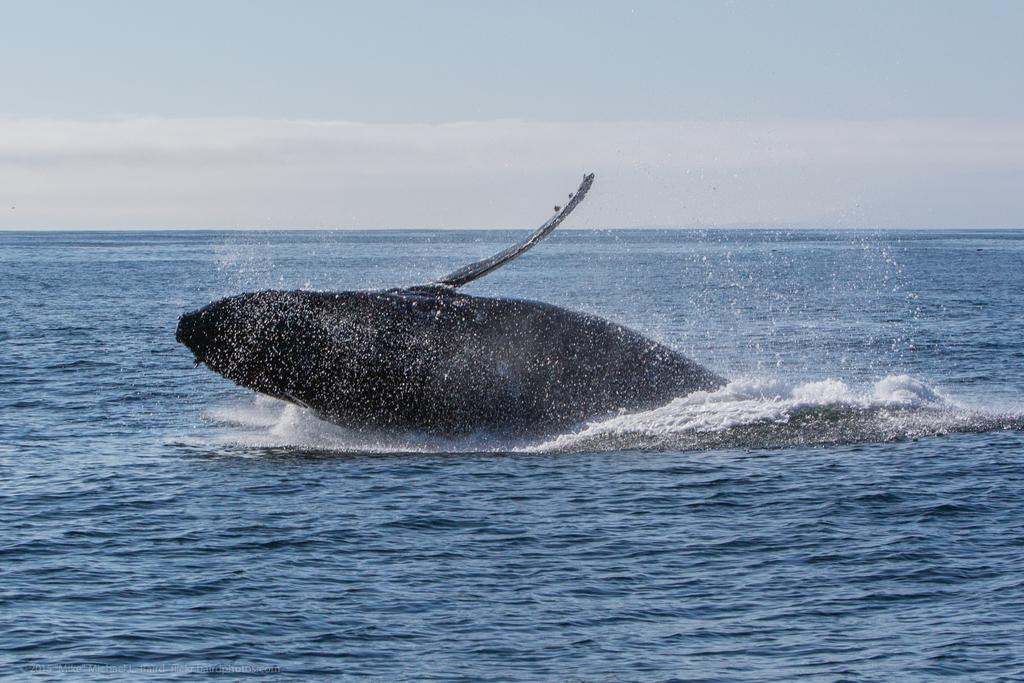What is in the water in the image? There is a whale in the water. What is the condition of the sky in the image? The sky is cloudy. What type of glue is being used to attach the sponge to the whale's head in the image? There is no glue or sponge present in the image; it features a whale in the water with a cloudy sky. 